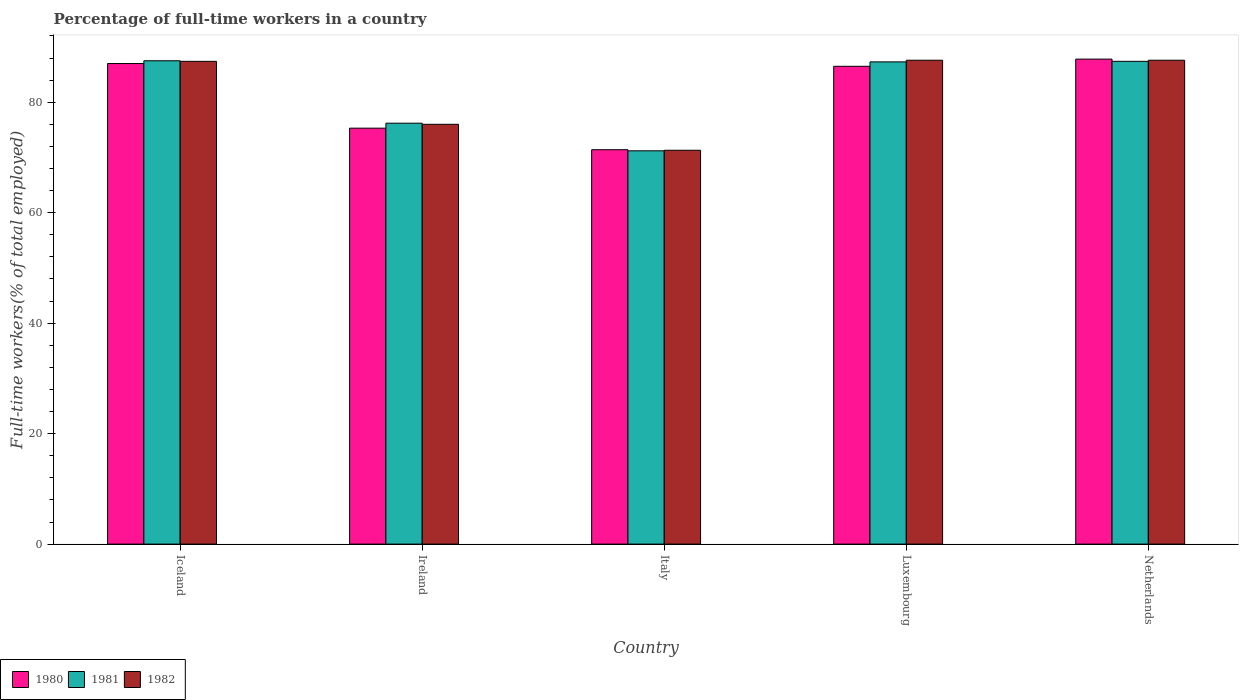How many different coloured bars are there?
Offer a very short reply. 3. Are the number of bars on each tick of the X-axis equal?
Ensure brevity in your answer.  Yes. How many bars are there on the 5th tick from the right?
Offer a terse response. 3. What is the label of the 3rd group of bars from the left?
Keep it short and to the point. Italy. What is the percentage of full-time workers in 1981 in Luxembourg?
Provide a short and direct response. 87.3. Across all countries, what is the maximum percentage of full-time workers in 1980?
Your response must be concise. 87.8. Across all countries, what is the minimum percentage of full-time workers in 1980?
Your answer should be compact. 71.4. In which country was the percentage of full-time workers in 1980 minimum?
Offer a very short reply. Italy. What is the total percentage of full-time workers in 1980 in the graph?
Offer a terse response. 408. What is the difference between the percentage of full-time workers in 1981 in Luxembourg and that in Netherlands?
Keep it short and to the point. -0.1. What is the difference between the percentage of full-time workers in 1982 in Ireland and the percentage of full-time workers in 1980 in Italy?
Your answer should be very brief. 4.6. What is the average percentage of full-time workers in 1981 per country?
Ensure brevity in your answer.  81.92. What is the difference between the percentage of full-time workers of/in 1982 and percentage of full-time workers of/in 1980 in Netherlands?
Ensure brevity in your answer.  -0.2. What is the ratio of the percentage of full-time workers in 1982 in Iceland to that in Luxembourg?
Give a very brief answer. 1. What is the difference between the highest and the second highest percentage of full-time workers in 1982?
Give a very brief answer. -0.2. What is the difference between the highest and the lowest percentage of full-time workers in 1982?
Your answer should be compact. 16.3. What does the 1st bar from the left in Luxembourg represents?
Ensure brevity in your answer.  1980. Are all the bars in the graph horizontal?
Provide a short and direct response. No. How many countries are there in the graph?
Your response must be concise. 5. What is the difference between two consecutive major ticks on the Y-axis?
Make the answer very short. 20. Are the values on the major ticks of Y-axis written in scientific E-notation?
Give a very brief answer. No. Does the graph contain any zero values?
Provide a short and direct response. No. Does the graph contain grids?
Your response must be concise. No. How are the legend labels stacked?
Your response must be concise. Horizontal. What is the title of the graph?
Your answer should be very brief. Percentage of full-time workers in a country. Does "2011" appear as one of the legend labels in the graph?
Offer a terse response. No. What is the label or title of the Y-axis?
Your answer should be very brief. Full-time workers(% of total employed). What is the Full-time workers(% of total employed) in 1980 in Iceland?
Ensure brevity in your answer.  87. What is the Full-time workers(% of total employed) in 1981 in Iceland?
Provide a short and direct response. 87.5. What is the Full-time workers(% of total employed) of 1982 in Iceland?
Your answer should be compact. 87.4. What is the Full-time workers(% of total employed) of 1980 in Ireland?
Keep it short and to the point. 75.3. What is the Full-time workers(% of total employed) of 1981 in Ireland?
Provide a short and direct response. 76.2. What is the Full-time workers(% of total employed) in 1982 in Ireland?
Provide a succinct answer. 76. What is the Full-time workers(% of total employed) of 1980 in Italy?
Make the answer very short. 71.4. What is the Full-time workers(% of total employed) in 1981 in Italy?
Offer a terse response. 71.2. What is the Full-time workers(% of total employed) in 1982 in Italy?
Your answer should be very brief. 71.3. What is the Full-time workers(% of total employed) in 1980 in Luxembourg?
Give a very brief answer. 86.5. What is the Full-time workers(% of total employed) of 1981 in Luxembourg?
Your answer should be very brief. 87.3. What is the Full-time workers(% of total employed) of 1982 in Luxembourg?
Ensure brevity in your answer.  87.6. What is the Full-time workers(% of total employed) in 1980 in Netherlands?
Your answer should be very brief. 87.8. What is the Full-time workers(% of total employed) in 1981 in Netherlands?
Make the answer very short. 87.4. What is the Full-time workers(% of total employed) in 1982 in Netherlands?
Your response must be concise. 87.6. Across all countries, what is the maximum Full-time workers(% of total employed) in 1980?
Provide a short and direct response. 87.8. Across all countries, what is the maximum Full-time workers(% of total employed) of 1981?
Provide a short and direct response. 87.5. Across all countries, what is the maximum Full-time workers(% of total employed) of 1982?
Ensure brevity in your answer.  87.6. Across all countries, what is the minimum Full-time workers(% of total employed) in 1980?
Give a very brief answer. 71.4. Across all countries, what is the minimum Full-time workers(% of total employed) of 1981?
Give a very brief answer. 71.2. Across all countries, what is the minimum Full-time workers(% of total employed) of 1982?
Your response must be concise. 71.3. What is the total Full-time workers(% of total employed) in 1980 in the graph?
Keep it short and to the point. 408. What is the total Full-time workers(% of total employed) in 1981 in the graph?
Provide a short and direct response. 409.6. What is the total Full-time workers(% of total employed) of 1982 in the graph?
Your answer should be compact. 409.9. What is the difference between the Full-time workers(% of total employed) of 1982 in Iceland and that in Ireland?
Your answer should be compact. 11.4. What is the difference between the Full-time workers(% of total employed) in 1980 in Iceland and that in Luxembourg?
Provide a short and direct response. 0.5. What is the difference between the Full-time workers(% of total employed) in 1981 in Iceland and that in Luxembourg?
Offer a very short reply. 0.2. What is the difference between the Full-time workers(% of total employed) in 1982 in Iceland and that in Luxembourg?
Offer a very short reply. -0.2. What is the difference between the Full-time workers(% of total employed) of 1981 in Iceland and that in Netherlands?
Provide a short and direct response. 0.1. What is the difference between the Full-time workers(% of total employed) of 1980 in Ireland and that in Italy?
Provide a short and direct response. 3.9. What is the difference between the Full-time workers(% of total employed) in 1981 in Ireland and that in Luxembourg?
Offer a very short reply. -11.1. What is the difference between the Full-time workers(% of total employed) of 1982 in Ireland and that in Netherlands?
Your answer should be compact. -11.6. What is the difference between the Full-time workers(% of total employed) of 1980 in Italy and that in Luxembourg?
Provide a succinct answer. -15.1. What is the difference between the Full-time workers(% of total employed) of 1981 in Italy and that in Luxembourg?
Your response must be concise. -16.1. What is the difference between the Full-time workers(% of total employed) of 1982 in Italy and that in Luxembourg?
Make the answer very short. -16.3. What is the difference between the Full-time workers(% of total employed) of 1980 in Italy and that in Netherlands?
Offer a very short reply. -16.4. What is the difference between the Full-time workers(% of total employed) of 1981 in Italy and that in Netherlands?
Your response must be concise. -16.2. What is the difference between the Full-time workers(% of total employed) in 1982 in Italy and that in Netherlands?
Your answer should be compact. -16.3. What is the difference between the Full-time workers(% of total employed) of 1980 in Luxembourg and that in Netherlands?
Provide a short and direct response. -1.3. What is the difference between the Full-time workers(% of total employed) in 1982 in Luxembourg and that in Netherlands?
Keep it short and to the point. 0. What is the difference between the Full-time workers(% of total employed) of 1981 in Iceland and the Full-time workers(% of total employed) of 1982 in Ireland?
Provide a short and direct response. 11.5. What is the difference between the Full-time workers(% of total employed) in 1980 in Iceland and the Full-time workers(% of total employed) in 1981 in Italy?
Keep it short and to the point. 15.8. What is the difference between the Full-time workers(% of total employed) in 1980 in Iceland and the Full-time workers(% of total employed) in 1981 in Luxembourg?
Your answer should be compact. -0.3. What is the difference between the Full-time workers(% of total employed) in 1980 in Iceland and the Full-time workers(% of total employed) in 1981 in Netherlands?
Ensure brevity in your answer.  -0.4. What is the difference between the Full-time workers(% of total employed) in 1980 in Iceland and the Full-time workers(% of total employed) in 1982 in Netherlands?
Provide a succinct answer. -0.6. What is the difference between the Full-time workers(% of total employed) of 1981 in Iceland and the Full-time workers(% of total employed) of 1982 in Netherlands?
Ensure brevity in your answer.  -0.1. What is the difference between the Full-time workers(% of total employed) in 1980 in Ireland and the Full-time workers(% of total employed) in 1981 in Italy?
Provide a short and direct response. 4.1. What is the difference between the Full-time workers(% of total employed) of 1980 in Ireland and the Full-time workers(% of total employed) of 1982 in Italy?
Provide a succinct answer. 4. What is the difference between the Full-time workers(% of total employed) of 1981 in Ireland and the Full-time workers(% of total employed) of 1982 in Italy?
Ensure brevity in your answer.  4.9. What is the difference between the Full-time workers(% of total employed) in 1980 in Ireland and the Full-time workers(% of total employed) in 1982 in Luxembourg?
Provide a succinct answer. -12.3. What is the difference between the Full-time workers(% of total employed) in 1981 in Ireland and the Full-time workers(% of total employed) in 1982 in Luxembourg?
Keep it short and to the point. -11.4. What is the difference between the Full-time workers(% of total employed) of 1981 in Ireland and the Full-time workers(% of total employed) of 1982 in Netherlands?
Provide a succinct answer. -11.4. What is the difference between the Full-time workers(% of total employed) of 1980 in Italy and the Full-time workers(% of total employed) of 1981 in Luxembourg?
Offer a terse response. -15.9. What is the difference between the Full-time workers(% of total employed) of 1980 in Italy and the Full-time workers(% of total employed) of 1982 in Luxembourg?
Provide a short and direct response. -16.2. What is the difference between the Full-time workers(% of total employed) in 1981 in Italy and the Full-time workers(% of total employed) in 1982 in Luxembourg?
Provide a short and direct response. -16.4. What is the difference between the Full-time workers(% of total employed) in 1980 in Italy and the Full-time workers(% of total employed) in 1982 in Netherlands?
Give a very brief answer. -16.2. What is the difference between the Full-time workers(% of total employed) of 1981 in Italy and the Full-time workers(% of total employed) of 1982 in Netherlands?
Give a very brief answer. -16.4. What is the difference between the Full-time workers(% of total employed) of 1980 in Luxembourg and the Full-time workers(% of total employed) of 1982 in Netherlands?
Offer a very short reply. -1.1. What is the difference between the Full-time workers(% of total employed) of 1981 in Luxembourg and the Full-time workers(% of total employed) of 1982 in Netherlands?
Keep it short and to the point. -0.3. What is the average Full-time workers(% of total employed) in 1980 per country?
Provide a short and direct response. 81.6. What is the average Full-time workers(% of total employed) of 1981 per country?
Your answer should be very brief. 81.92. What is the average Full-time workers(% of total employed) in 1982 per country?
Your response must be concise. 81.98. What is the difference between the Full-time workers(% of total employed) in 1980 and Full-time workers(% of total employed) in 1981 in Iceland?
Provide a succinct answer. -0.5. What is the difference between the Full-time workers(% of total employed) in 1981 and Full-time workers(% of total employed) in 1982 in Iceland?
Your response must be concise. 0.1. What is the difference between the Full-time workers(% of total employed) of 1980 and Full-time workers(% of total employed) of 1982 in Ireland?
Your response must be concise. -0.7. What is the difference between the Full-time workers(% of total employed) of 1981 and Full-time workers(% of total employed) of 1982 in Ireland?
Your answer should be very brief. 0.2. What is the difference between the Full-time workers(% of total employed) in 1980 and Full-time workers(% of total employed) in 1981 in Italy?
Give a very brief answer. 0.2. What is the difference between the Full-time workers(% of total employed) of 1981 and Full-time workers(% of total employed) of 1982 in Luxembourg?
Provide a succinct answer. -0.3. What is the difference between the Full-time workers(% of total employed) in 1980 and Full-time workers(% of total employed) in 1982 in Netherlands?
Your response must be concise. 0.2. What is the ratio of the Full-time workers(% of total employed) in 1980 in Iceland to that in Ireland?
Provide a short and direct response. 1.16. What is the ratio of the Full-time workers(% of total employed) in 1981 in Iceland to that in Ireland?
Your answer should be compact. 1.15. What is the ratio of the Full-time workers(% of total employed) of 1982 in Iceland to that in Ireland?
Give a very brief answer. 1.15. What is the ratio of the Full-time workers(% of total employed) in 1980 in Iceland to that in Italy?
Your answer should be very brief. 1.22. What is the ratio of the Full-time workers(% of total employed) in 1981 in Iceland to that in Italy?
Your response must be concise. 1.23. What is the ratio of the Full-time workers(% of total employed) in 1982 in Iceland to that in Italy?
Offer a terse response. 1.23. What is the ratio of the Full-time workers(% of total employed) of 1980 in Iceland to that in Luxembourg?
Offer a terse response. 1.01. What is the ratio of the Full-time workers(% of total employed) in 1981 in Iceland to that in Luxembourg?
Your answer should be very brief. 1. What is the ratio of the Full-time workers(% of total employed) of 1982 in Iceland to that in Luxembourg?
Give a very brief answer. 1. What is the ratio of the Full-time workers(% of total employed) in 1980 in Iceland to that in Netherlands?
Make the answer very short. 0.99. What is the ratio of the Full-time workers(% of total employed) of 1982 in Iceland to that in Netherlands?
Your answer should be very brief. 1. What is the ratio of the Full-time workers(% of total employed) of 1980 in Ireland to that in Italy?
Make the answer very short. 1.05. What is the ratio of the Full-time workers(% of total employed) in 1981 in Ireland to that in Italy?
Make the answer very short. 1.07. What is the ratio of the Full-time workers(% of total employed) in 1982 in Ireland to that in Italy?
Your response must be concise. 1.07. What is the ratio of the Full-time workers(% of total employed) in 1980 in Ireland to that in Luxembourg?
Ensure brevity in your answer.  0.87. What is the ratio of the Full-time workers(% of total employed) of 1981 in Ireland to that in Luxembourg?
Provide a short and direct response. 0.87. What is the ratio of the Full-time workers(% of total employed) in 1982 in Ireland to that in Luxembourg?
Offer a terse response. 0.87. What is the ratio of the Full-time workers(% of total employed) in 1980 in Ireland to that in Netherlands?
Your response must be concise. 0.86. What is the ratio of the Full-time workers(% of total employed) in 1981 in Ireland to that in Netherlands?
Ensure brevity in your answer.  0.87. What is the ratio of the Full-time workers(% of total employed) of 1982 in Ireland to that in Netherlands?
Your response must be concise. 0.87. What is the ratio of the Full-time workers(% of total employed) of 1980 in Italy to that in Luxembourg?
Offer a terse response. 0.83. What is the ratio of the Full-time workers(% of total employed) in 1981 in Italy to that in Luxembourg?
Your response must be concise. 0.82. What is the ratio of the Full-time workers(% of total employed) of 1982 in Italy to that in Luxembourg?
Keep it short and to the point. 0.81. What is the ratio of the Full-time workers(% of total employed) in 1980 in Italy to that in Netherlands?
Keep it short and to the point. 0.81. What is the ratio of the Full-time workers(% of total employed) in 1981 in Italy to that in Netherlands?
Ensure brevity in your answer.  0.81. What is the ratio of the Full-time workers(% of total employed) of 1982 in Italy to that in Netherlands?
Ensure brevity in your answer.  0.81. What is the ratio of the Full-time workers(% of total employed) of 1980 in Luxembourg to that in Netherlands?
Offer a terse response. 0.99. What is the ratio of the Full-time workers(% of total employed) in 1981 in Luxembourg to that in Netherlands?
Provide a short and direct response. 1. What is the difference between the highest and the lowest Full-time workers(% of total employed) of 1980?
Your answer should be compact. 16.4. 